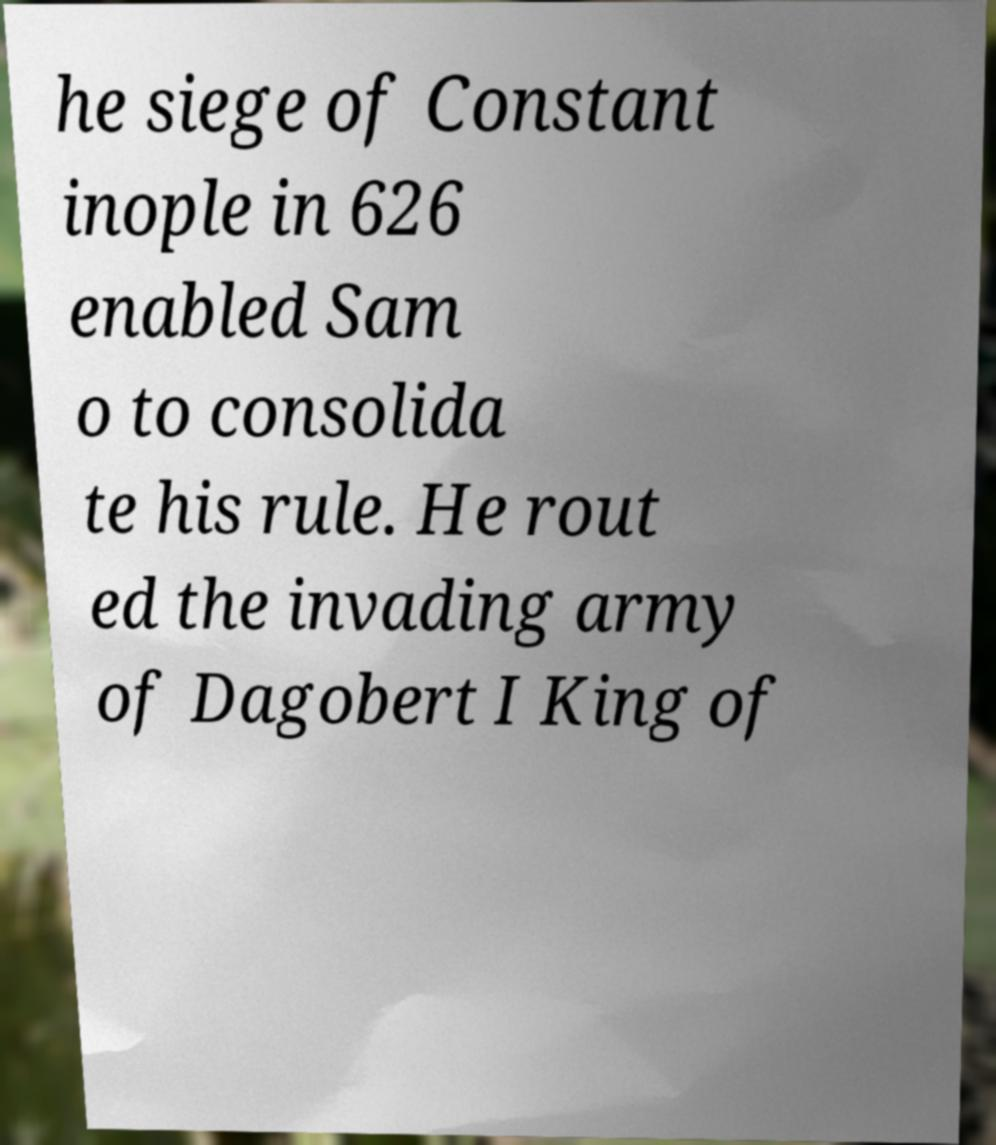Can you read and provide the text displayed in the image?This photo seems to have some interesting text. Can you extract and type it out for me? he siege of Constant inople in 626 enabled Sam o to consolida te his rule. He rout ed the invading army of Dagobert I King of 